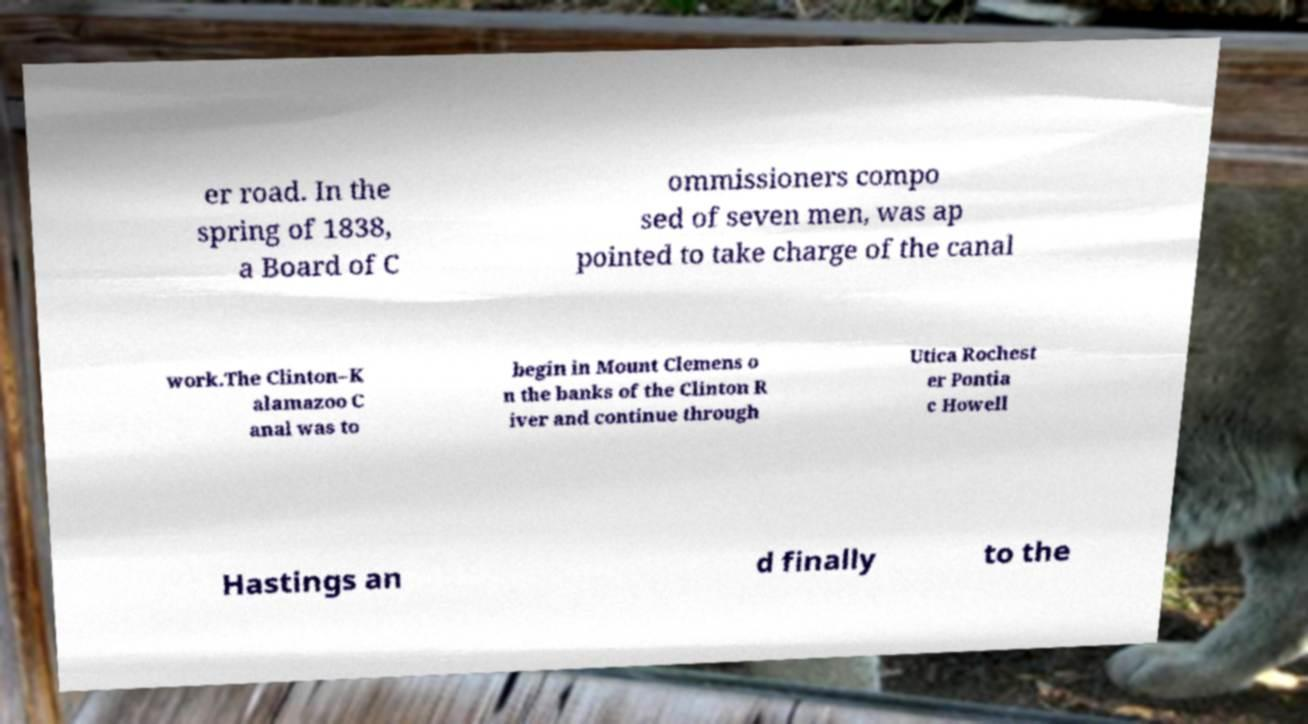Please read and relay the text visible in this image. What does it say? er road. In the spring of 1838, a Board of C ommissioners compo sed of seven men, was ap pointed to take charge of the canal work.The Clinton–K alamazoo C anal was to begin in Mount Clemens o n the banks of the Clinton R iver and continue through Utica Rochest er Pontia c Howell Hastings an d finally to the 